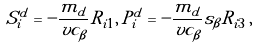Convert formula to latex. <formula><loc_0><loc_0><loc_500><loc_500>S ^ { d } _ { i } = - \frac { m _ { d } } { v c _ { \beta } } R _ { i 1 } , \, P ^ { d } _ { i } = - \frac { m _ { d } } { v c _ { \beta } } s _ { \beta } R _ { i 3 } \, ,</formula> 